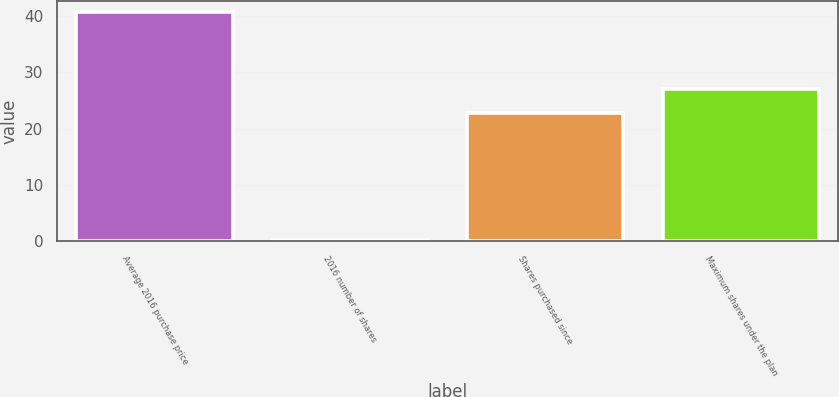<chart> <loc_0><loc_0><loc_500><loc_500><bar_chart><fcel>Average 2016 purchase price<fcel>2016 number of shares<fcel>Shares purchased since<fcel>Maximum shares under the plan<nl><fcel>40.73<fcel>0.1<fcel>22.8<fcel>27<nl></chart> 